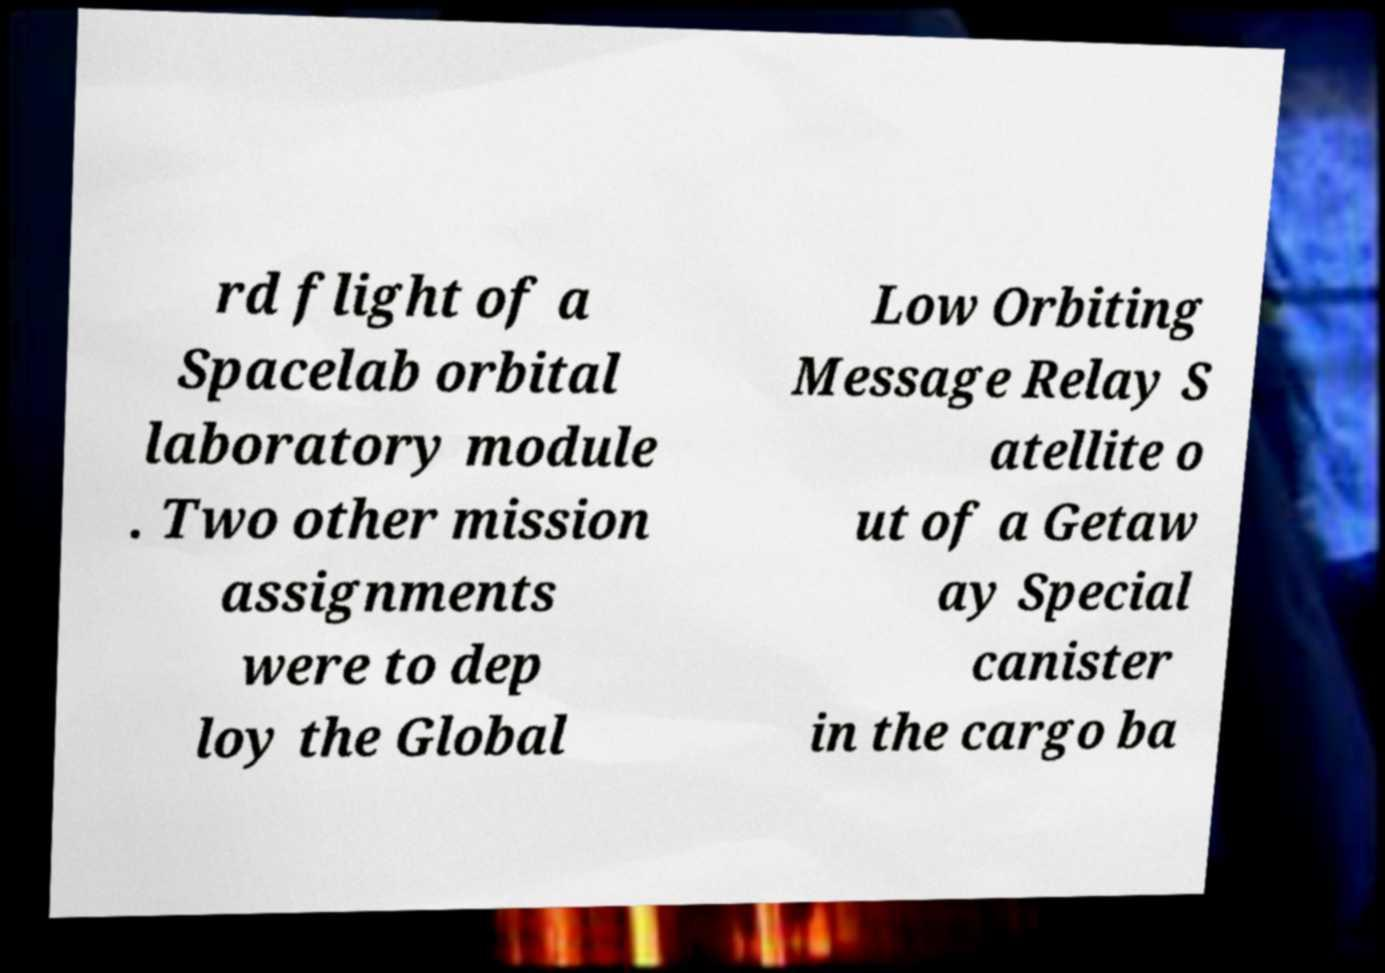Please identify and transcribe the text found in this image. rd flight of a Spacelab orbital laboratory module . Two other mission assignments were to dep loy the Global Low Orbiting Message Relay S atellite o ut of a Getaw ay Special canister in the cargo ba 